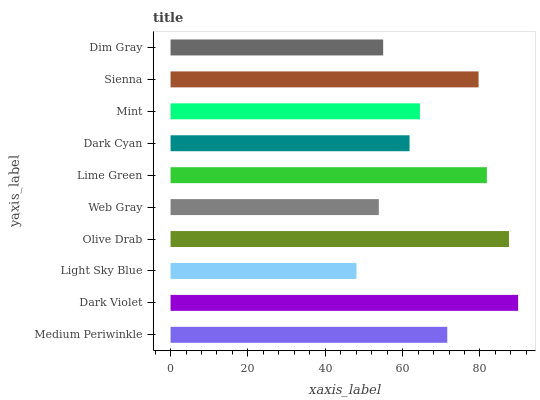Is Light Sky Blue the minimum?
Answer yes or no. Yes. Is Dark Violet the maximum?
Answer yes or no. Yes. Is Dark Violet the minimum?
Answer yes or no. No. Is Light Sky Blue the maximum?
Answer yes or no. No. Is Dark Violet greater than Light Sky Blue?
Answer yes or no. Yes. Is Light Sky Blue less than Dark Violet?
Answer yes or no. Yes. Is Light Sky Blue greater than Dark Violet?
Answer yes or no. No. Is Dark Violet less than Light Sky Blue?
Answer yes or no. No. Is Medium Periwinkle the high median?
Answer yes or no. Yes. Is Mint the low median?
Answer yes or no. Yes. Is Olive Drab the high median?
Answer yes or no. No. Is Dim Gray the low median?
Answer yes or no. No. 